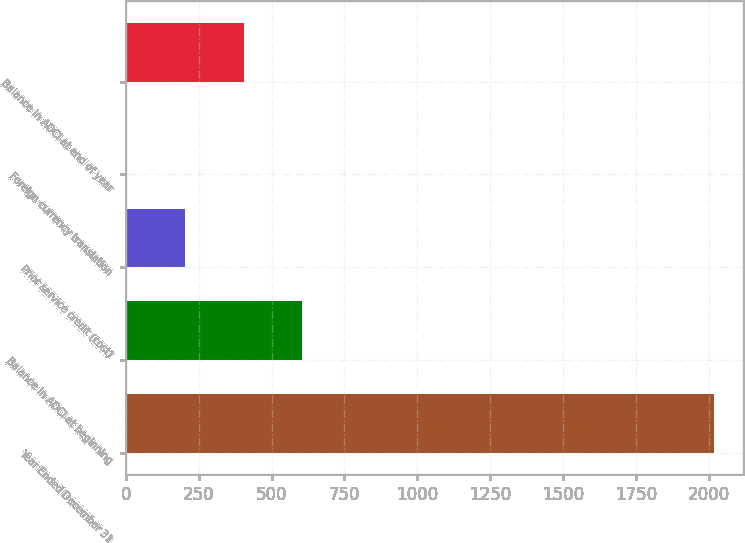Convert chart. <chart><loc_0><loc_0><loc_500><loc_500><bar_chart><fcel>Year Ended December 31<fcel>Balance in AOCI at beginning<fcel>Prior service credit (cost)<fcel>Foreign currency translation<fcel>Balance in AOCI at end of year<nl><fcel>2017<fcel>605.8<fcel>202.6<fcel>1<fcel>404.2<nl></chart> 